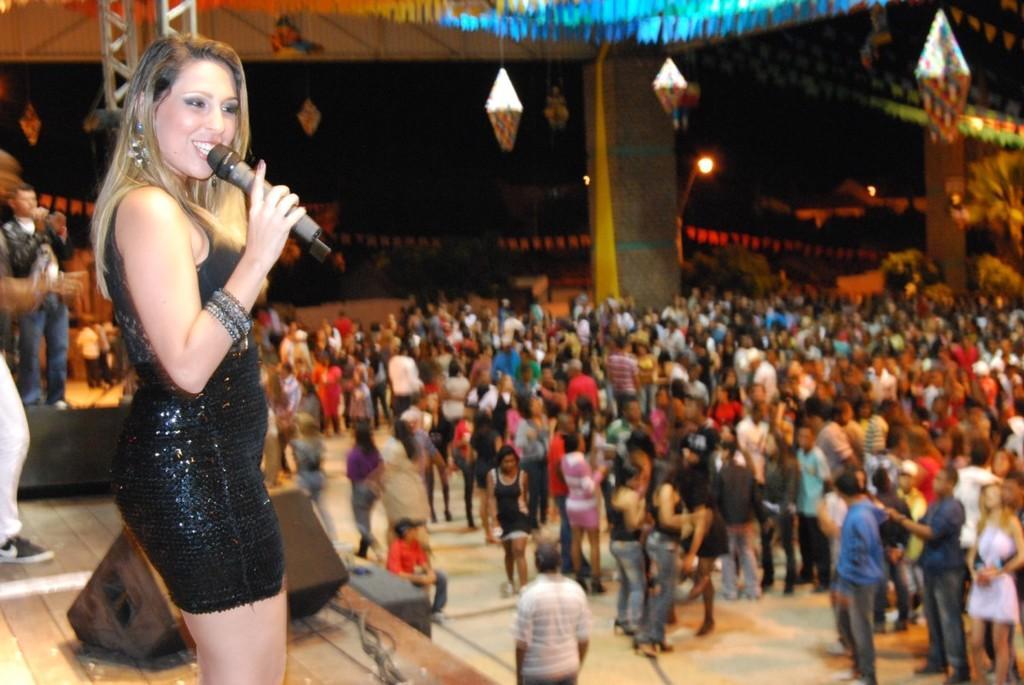In one or two sentences, can you explain what this image depicts? In the picture I can see a group of people are standing on the ground. I can also see a woman is standing on a wooden surface and holding a microphone in the hand. In the background I can see a pillar, lights and some other things. The background of the image is blurred. 